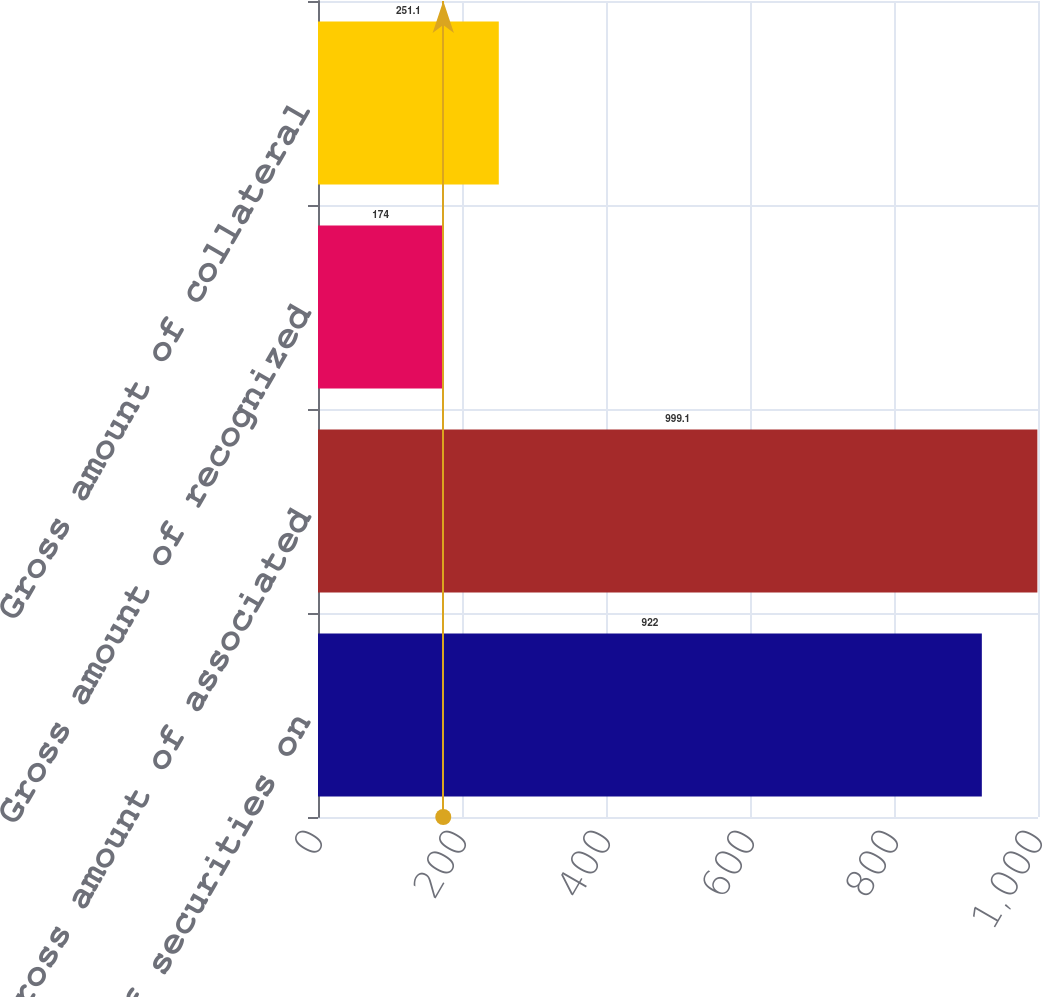Convert chart to OTSL. <chart><loc_0><loc_0><loc_500><loc_500><bar_chart><fcel>Gross amount of securities on<fcel>Gross amount of associated<fcel>Gross amount of recognized<fcel>Gross amount of collateral<nl><fcel>922<fcel>999.1<fcel>174<fcel>251.1<nl></chart> 